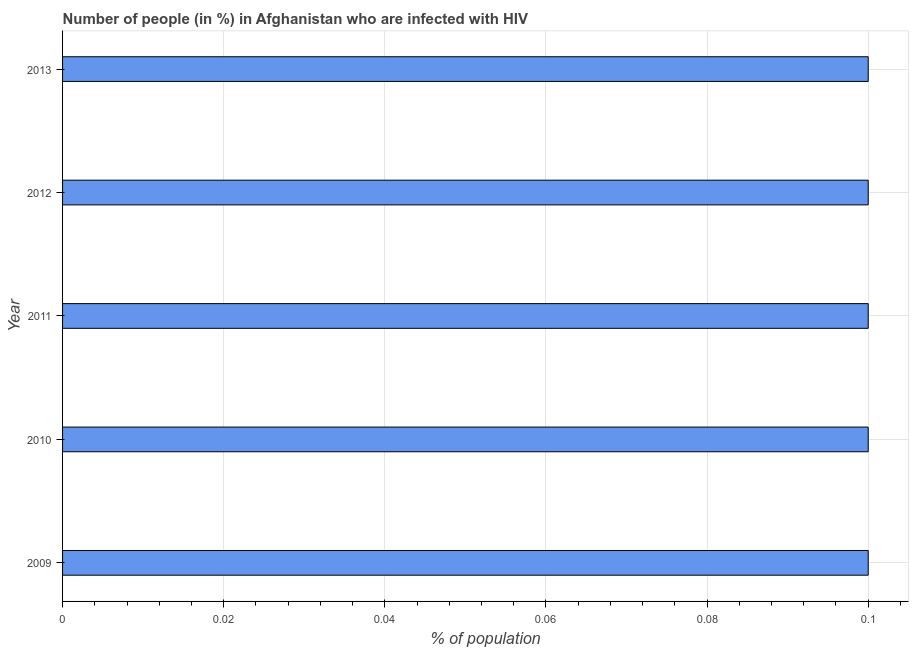Does the graph contain grids?
Offer a terse response. Yes. What is the title of the graph?
Your response must be concise. Number of people (in %) in Afghanistan who are infected with HIV. What is the label or title of the X-axis?
Offer a terse response. % of population. Across all years, what is the minimum number of people infected with hiv?
Your answer should be very brief. 0.1. In which year was the number of people infected with hiv maximum?
Offer a terse response. 2009. What is the difference between the number of people infected with hiv in 2009 and 2013?
Your response must be concise. 0. What is the average number of people infected with hiv per year?
Offer a terse response. 0.1. What is the median number of people infected with hiv?
Provide a short and direct response. 0.1. Do a majority of the years between 2011 and 2012 (inclusive) have number of people infected with hiv greater than 0.088 %?
Give a very brief answer. Yes. What is the ratio of the number of people infected with hiv in 2010 to that in 2011?
Your response must be concise. 1. Is the number of people infected with hiv in 2010 less than that in 2012?
Give a very brief answer. No. What is the difference between two consecutive major ticks on the X-axis?
Your response must be concise. 0.02. Are the values on the major ticks of X-axis written in scientific E-notation?
Ensure brevity in your answer.  No. What is the % of population of 2009?
Ensure brevity in your answer.  0.1. What is the difference between the % of population in 2009 and 2012?
Your answer should be compact. 0. What is the difference between the % of population in 2009 and 2013?
Ensure brevity in your answer.  0. What is the difference between the % of population in 2010 and 2012?
Your answer should be very brief. 0. What is the difference between the % of population in 2011 and 2012?
Ensure brevity in your answer.  0. What is the difference between the % of population in 2011 and 2013?
Provide a succinct answer. 0. What is the difference between the % of population in 2012 and 2013?
Your answer should be very brief. 0. What is the ratio of the % of population in 2009 to that in 2010?
Give a very brief answer. 1. What is the ratio of the % of population in 2009 to that in 2011?
Provide a short and direct response. 1. What is the ratio of the % of population in 2010 to that in 2011?
Your response must be concise. 1. What is the ratio of the % of population in 2010 to that in 2013?
Your answer should be compact. 1. What is the ratio of the % of population in 2011 to that in 2012?
Ensure brevity in your answer.  1. What is the ratio of the % of population in 2011 to that in 2013?
Make the answer very short. 1. What is the ratio of the % of population in 2012 to that in 2013?
Offer a terse response. 1. 